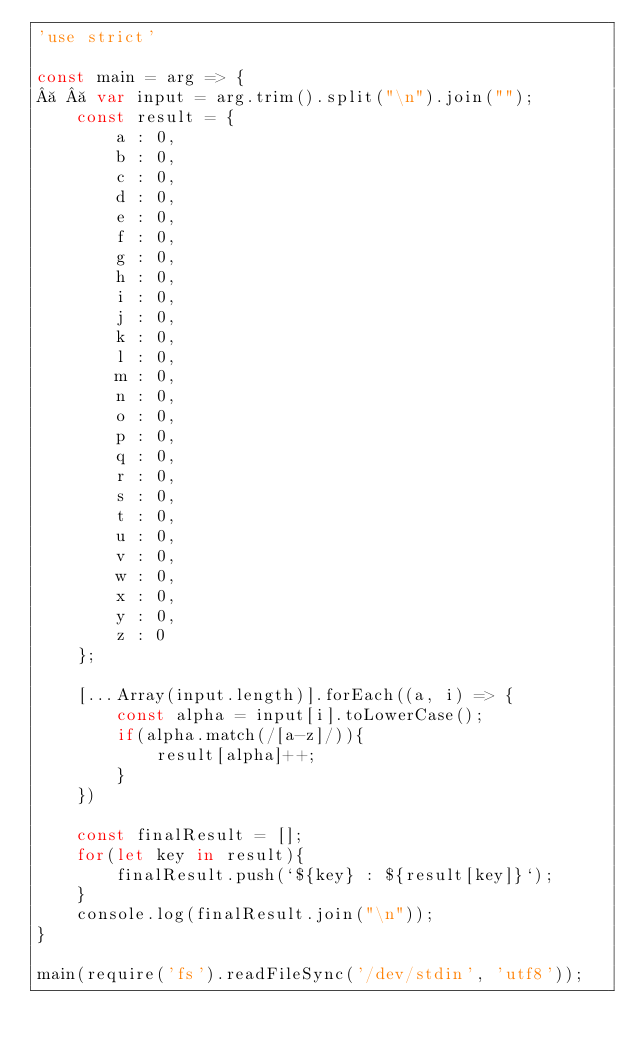<code> <loc_0><loc_0><loc_500><loc_500><_JavaScript_>'use strict'

const main = arg => {
    var input = arg.trim().split("\n").join("");
    const result = {
        a : 0,
        b : 0,
        c : 0,
        d : 0,
        e : 0,
        f : 0,
        g : 0,
        h : 0,
        i : 0,
        j : 0,
        k : 0,
        l : 0,
        m : 0,
        n : 0,
        o : 0,
        p : 0,
        q : 0,
        r : 0,
        s : 0,
        t : 0,
        u : 0,
        v : 0,
        w : 0,
        x : 0,
        y : 0,
        z : 0
    };

    [...Array(input.length)].forEach((a, i) => {
        const alpha = input[i].toLowerCase();
        if(alpha.match(/[a-z]/)){
            result[alpha]++;
        }
    })

    const finalResult = [];
    for(let key in result){
        finalResult.push(`${key} : ${result[key]}`);
    }
    console.log(finalResult.join("\n"));
}

main(require('fs').readFileSync('/dev/stdin', 'utf8'));
</code> 